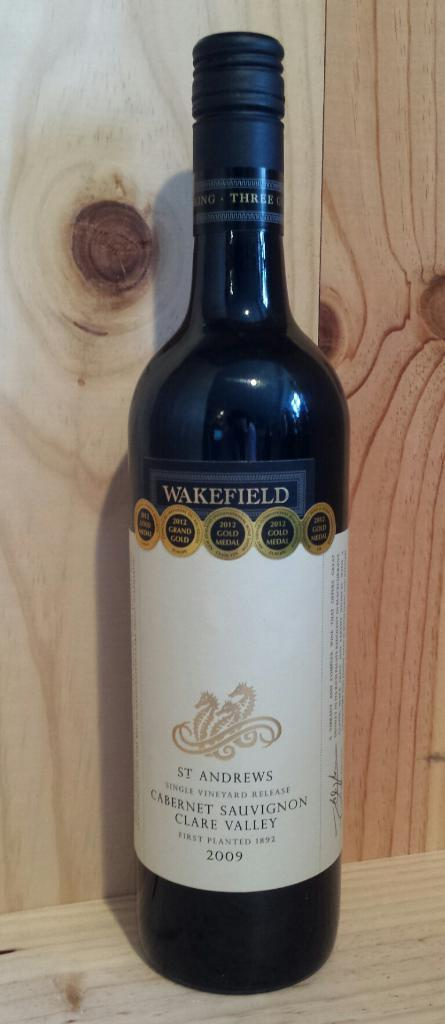<image>
Relay a brief, clear account of the picture shown. A bottle of wine, from 2009, is labelled St Andrews Cabernet Sauvignon Clare Valley. 